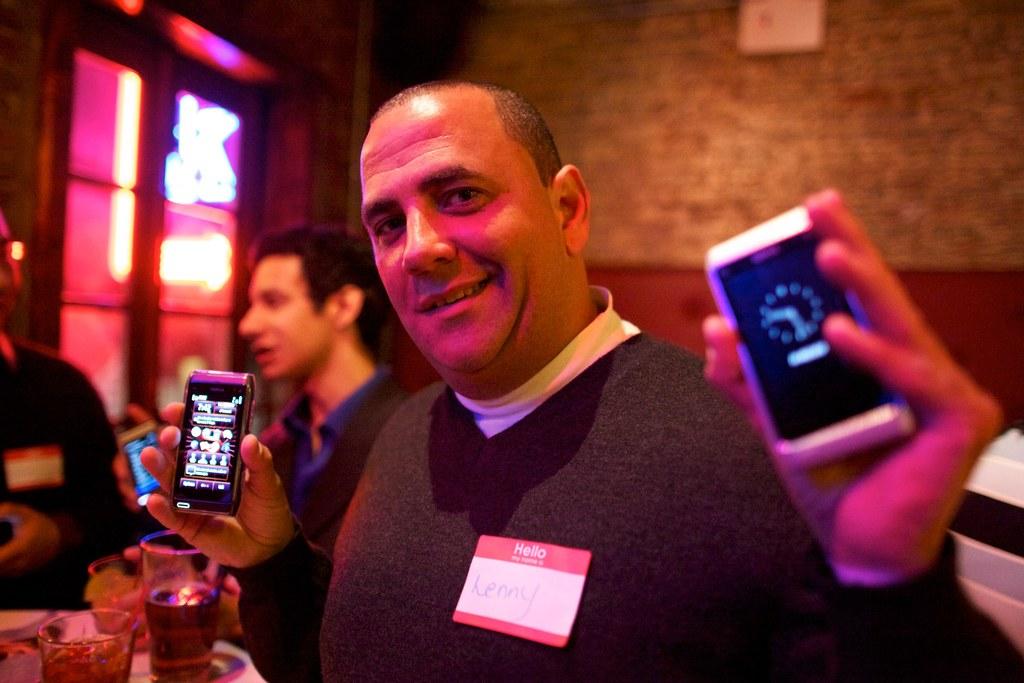What is the name of the guy with a name tag?
Keep it short and to the point. Lenny. 